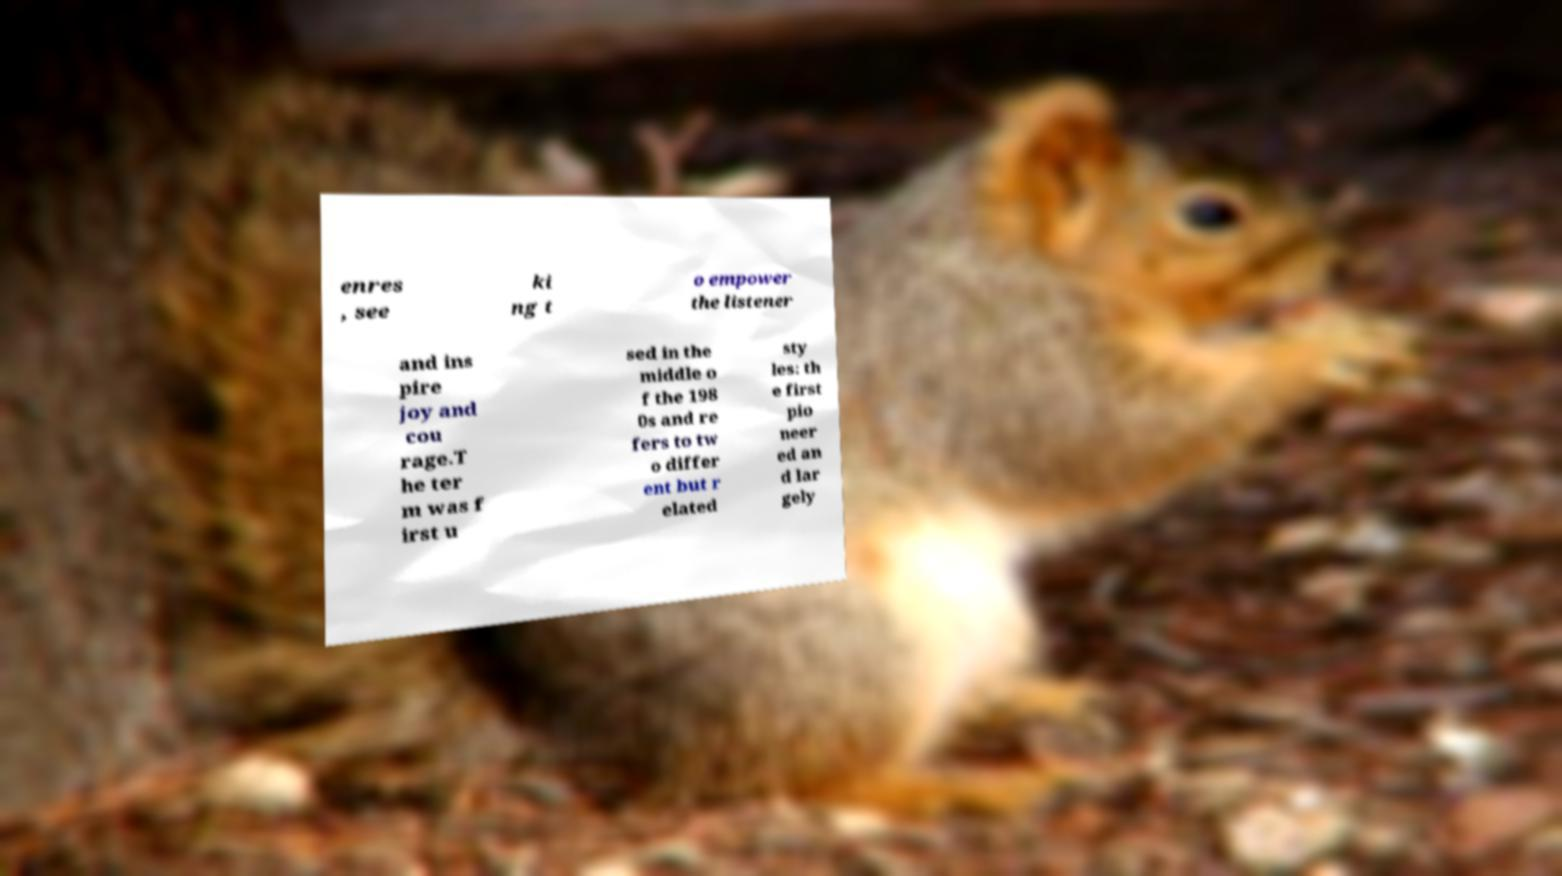Please read and relay the text visible in this image. What does it say? enres , see ki ng t o empower the listener and ins pire joy and cou rage.T he ter m was f irst u sed in the middle o f the 198 0s and re fers to tw o differ ent but r elated sty les: th e first pio neer ed an d lar gely 